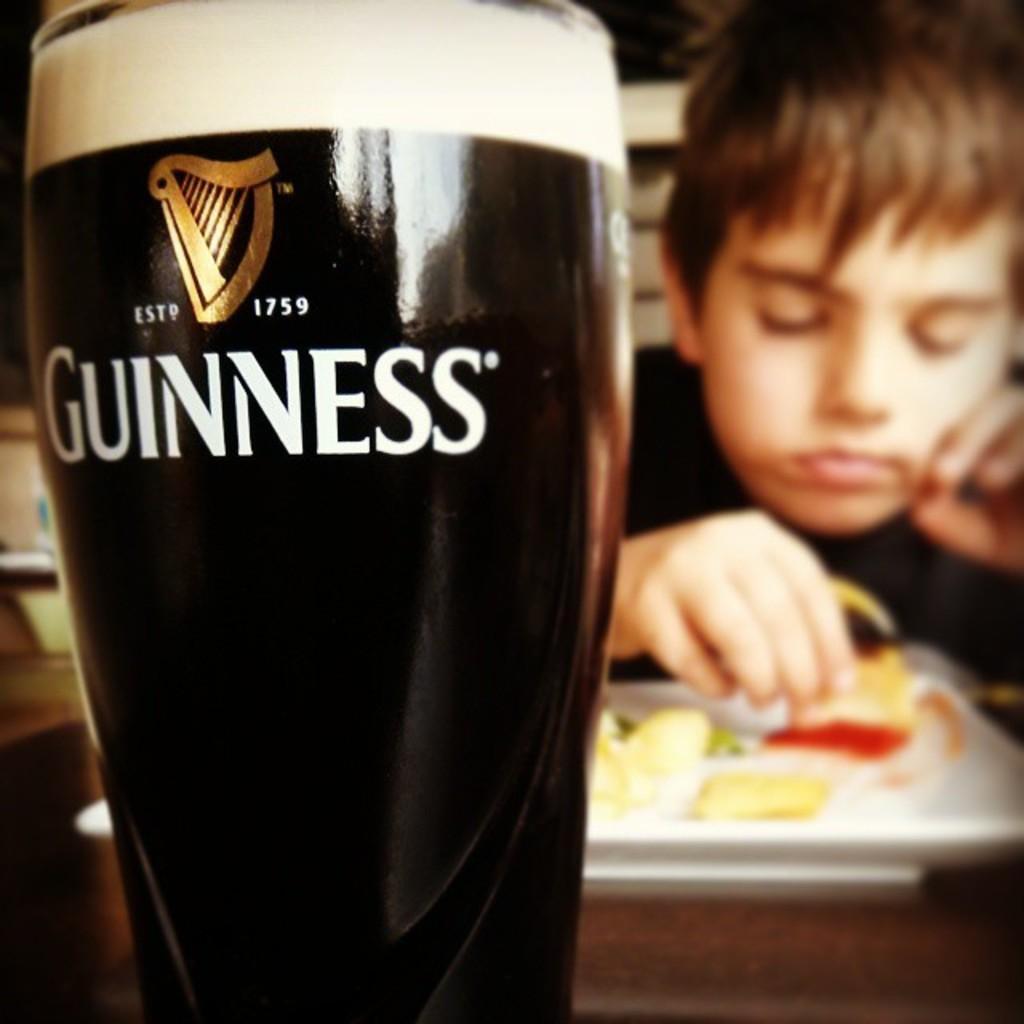Describe this image in one or two sentences. In this picture there is a glass on the left side of the image and there is a boy in front of a food plate on the right side of the image. 